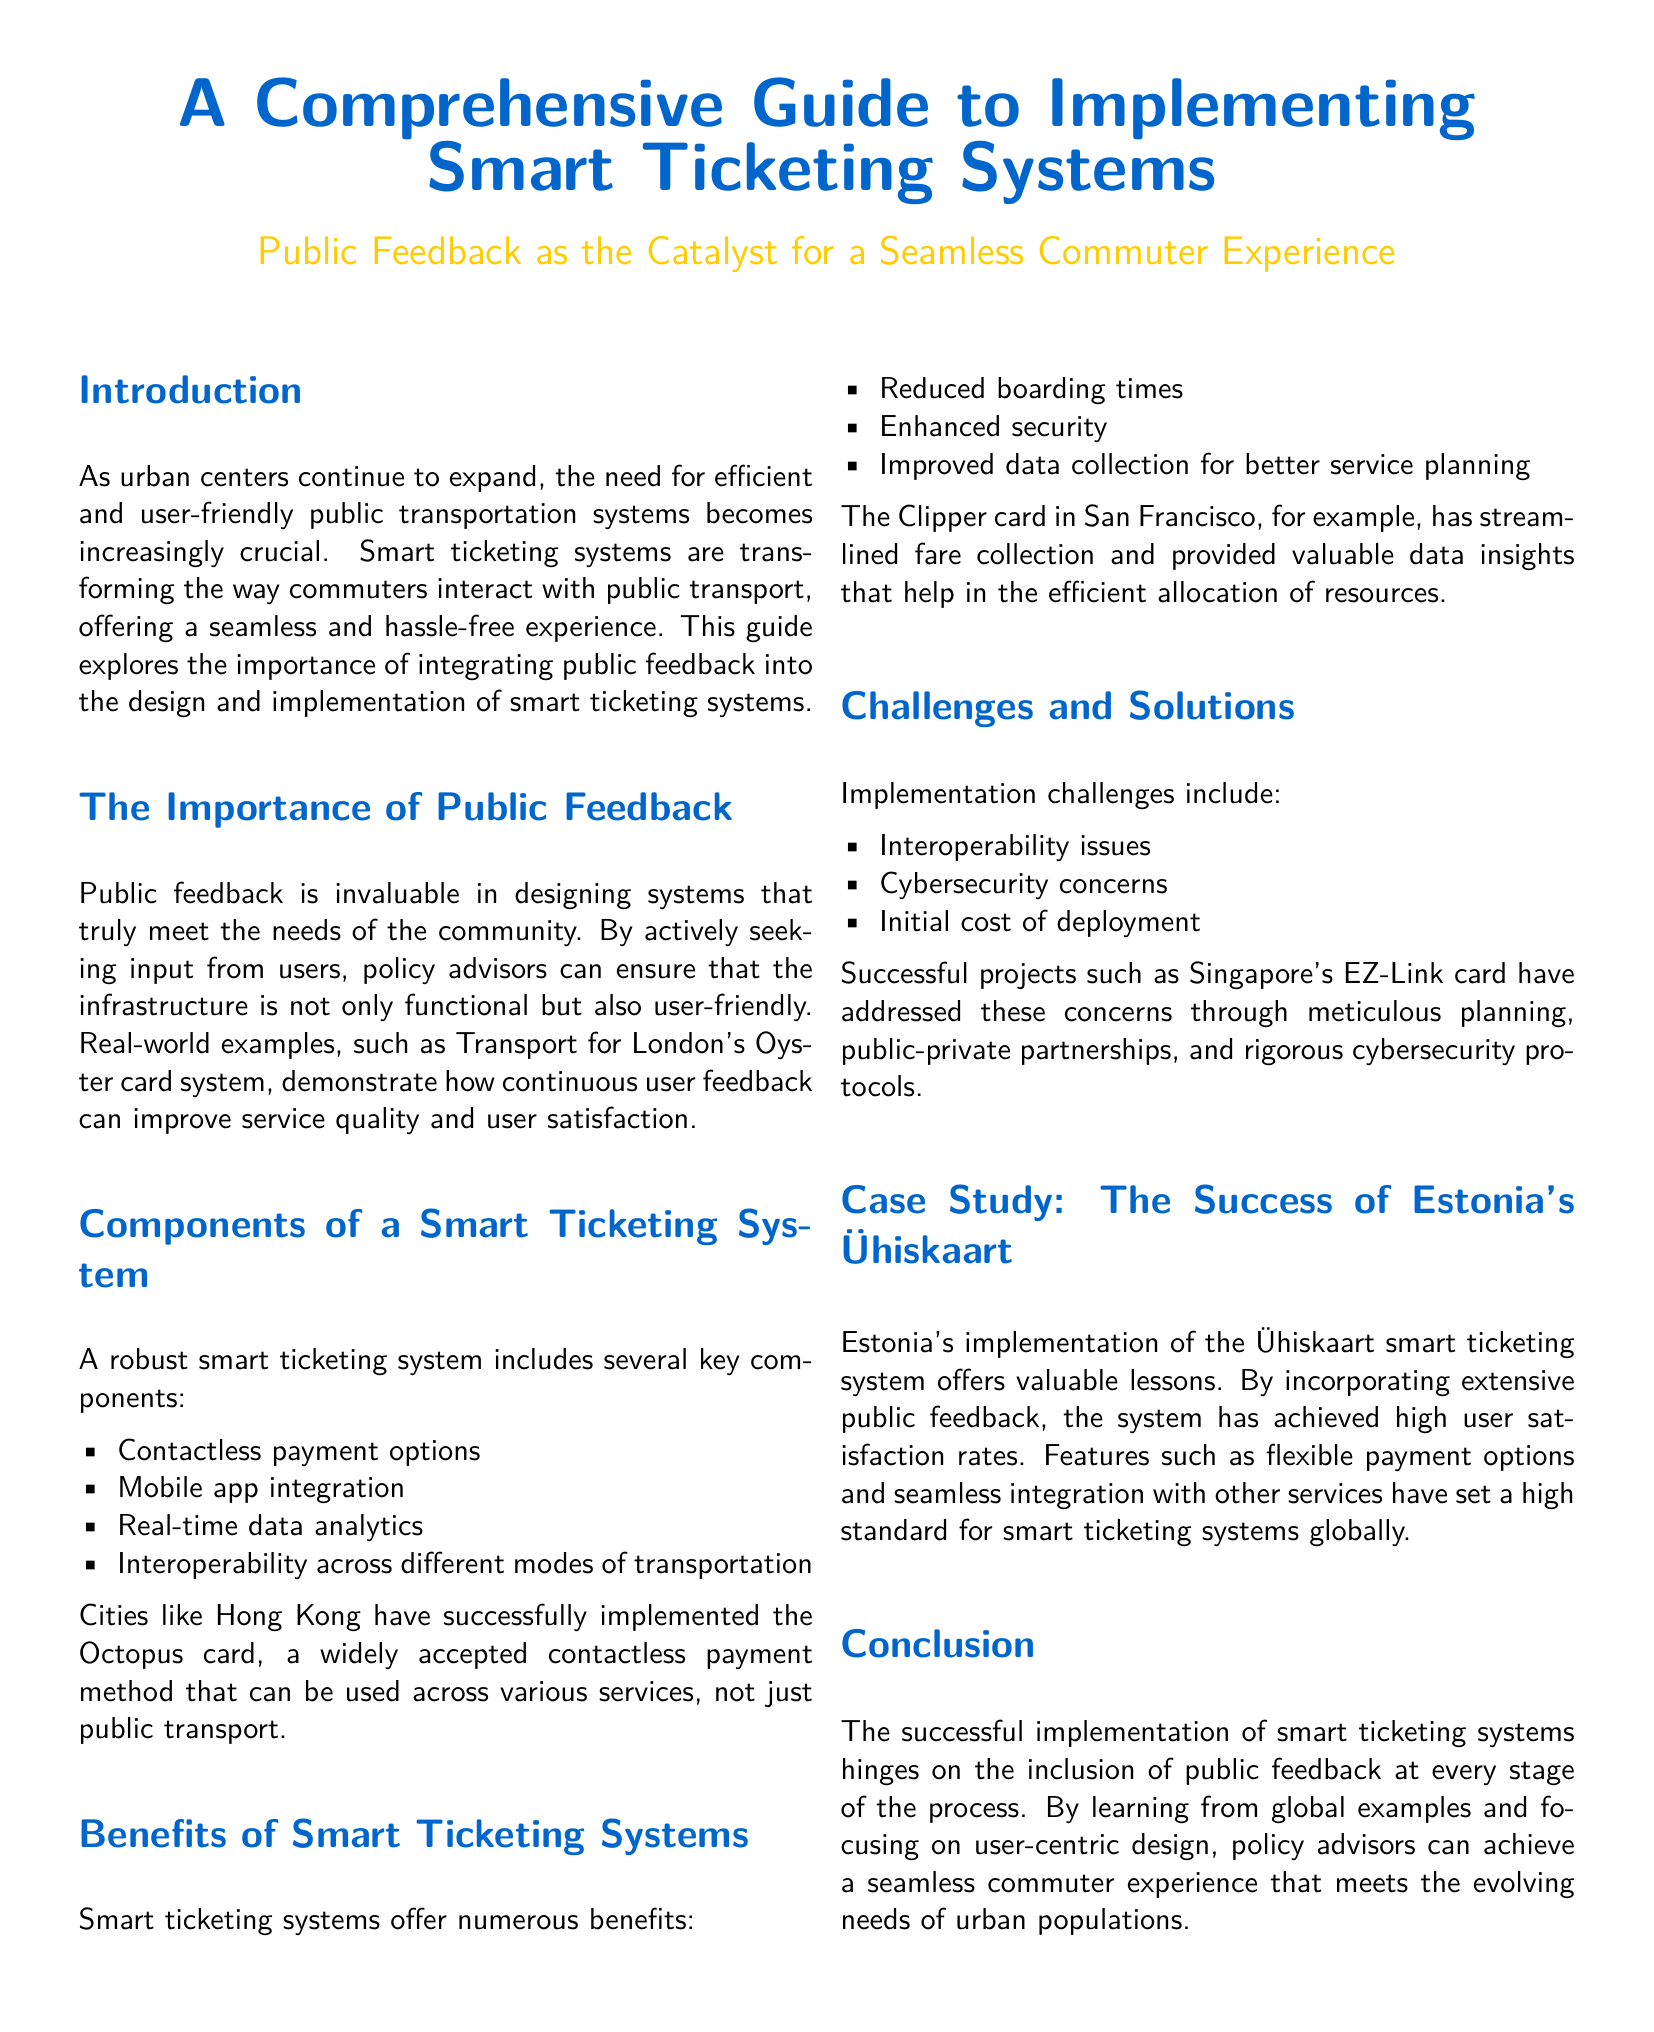What is the title of the document? The title is the main heading of the whitepaper, reflecting its content and purpose.
Answer: A Comprehensive Guide to Implementing Smart Ticketing Systems What is the secondary title of the document? The secondary title elaborates on the main title and clarifies the focus on public feedback.
Answer: Public Feedback as the Catalyst for a Seamless Commuter Experience Which system is referred to as an example of effective public feedback integration? The example provided illustrates how user feedback has improved a public transport system.
Answer: Transport for London's Oyster card system What is one key component of a smart ticketing system? The document lists several components that define a smart ticketing system.
Answer: Contactless payment options What is one benefit of smart ticketing systems? The benefits highlight the positive outcomes and efficiencies provided by these systems.
Answer: Reduced boarding times What major challenge is associated with implementing smart ticketing systems? The document outlines various challenges that need to be addressed during implementation.
Answer: Interoperability issues Which card system is highlighted as a successful project in Singapore? This refers to a specific technology used in Singapore for public transportation and related services.
Answer: EZ-Link card What system does Estonia use for smart ticketing? This identifies the specific system implemented in Estonia based on public feedback.
Answer: Ühiskaart What is a crucial factor for the successful implementation of smart ticketing systems? The document emphasizes a key aspect that influences the success of these systems during implementation.
Answer: Inclusion of public feedback 